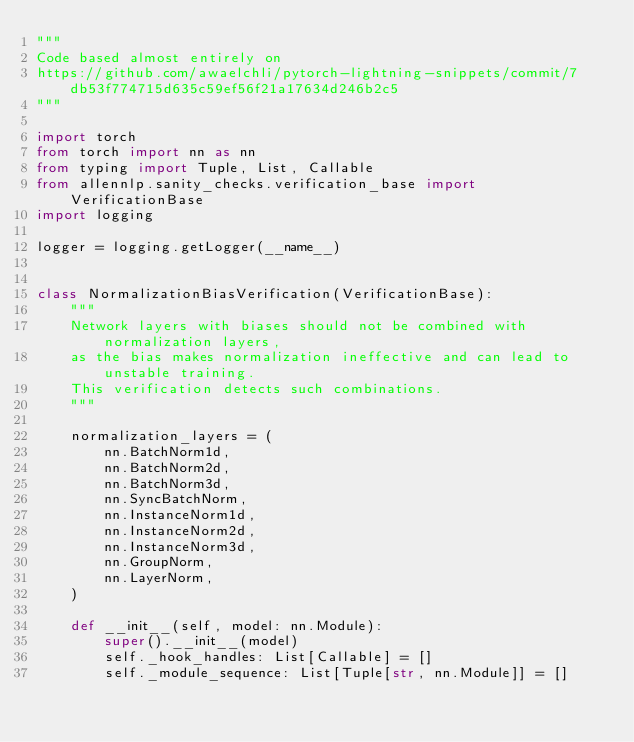Convert code to text. <code><loc_0><loc_0><loc_500><loc_500><_Python_>"""
Code based almost entirely on
https://github.com/awaelchli/pytorch-lightning-snippets/commit/7db53f774715d635c59ef56f21a17634d246b2c5
"""

import torch
from torch import nn as nn
from typing import Tuple, List, Callable
from allennlp.sanity_checks.verification_base import VerificationBase
import logging

logger = logging.getLogger(__name__)


class NormalizationBiasVerification(VerificationBase):
    """
    Network layers with biases should not be combined with normalization layers,
    as the bias makes normalization ineffective and can lead to unstable training.
    This verification detects such combinations.
    """

    normalization_layers = (
        nn.BatchNorm1d,
        nn.BatchNorm2d,
        nn.BatchNorm3d,
        nn.SyncBatchNorm,
        nn.InstanceNorm1d,
        nn.InstanceNorm2d,
        nn.InstanceNorm3d,
        nn.GroupNorm,
        nn.LayerNorm,
    )

    def __init__(self, model: nn.Module):
        super().__init__(model)
        self._hook_handles: List[Callable] = []
        self._module_sequence: List[Tuple[str, nn.Module]] = []</code> 